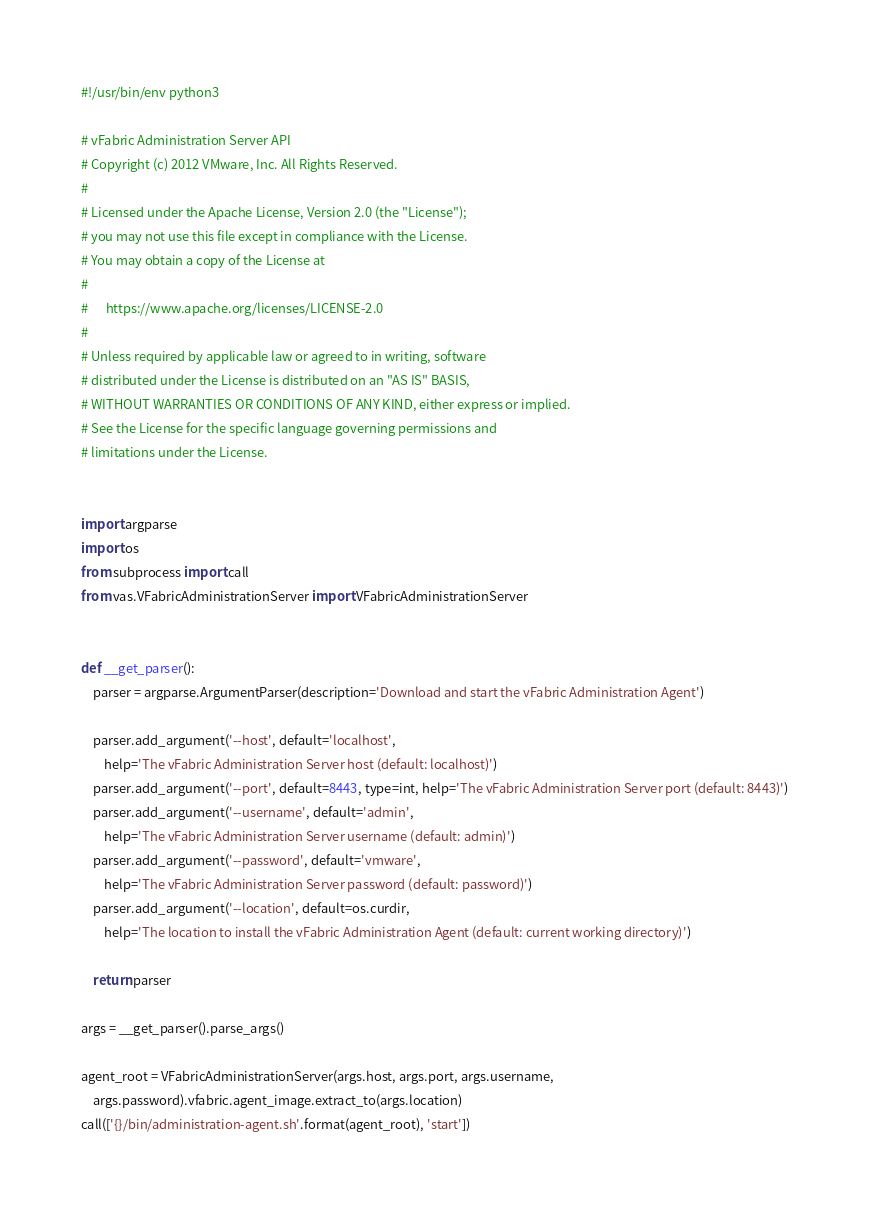Convert code to text. <code><loc_0><loc_0><loc_500><loc_500><_Python_>#!/usr/bin/env python3

# vFabric Administration Server API
# Copyright (c) 2012 VMware, Inc. All Rights Reserved.
#
# Licensed under the Apache License, Version 2.0 (the "License");
# you may not use this file except in compliance with the License.
# You may obtain a copy of the License at
#
#      https://www.apache.org/licenses/LICENSE-2.0
#
# Unless required by applicable law or agreed to in writing, software
# distributed under the License is distributed on an "AS IS" BASIS,
# WITHOUT WARRANTIES OR CONDITIONS OF ANY KIND, either express or implied.
# See the License for the specific language governing permissions and
# limitations under the License.


import argparse
import os
from subprocess import call
from vas.VFabricAdministrationServer import VFabricAdministrationServer


def __get_parser():
    parser = argparse.ArgumentParser(description='Download and start the vFabric Administration Agent')

    parser.add_argument('--host', default='localhost',
        help='The vFabric Administration Server host (default: localhost)')
    parser.add_argument('--port', default=8443, type=int, help='The vFabric Administration Server port (default: 8443)')
    parser.add_argument('--username', default='admin',
        help='The vFabric Administration Server username (default: admin)')
    parser.add_argument('--password', default='vmware',
        help='The vFabric Administration Server password (default: password)')
    parser.add_argument('--location', default=os.curdir,
        help='The location to install the vFabric Administration Agent (default: current working directory)')

    return parser

args = __get_parser().parse_args()

agent_root = VFabricAdministrationServer(args.host, args.port, args.username,
    args.password).vfabric.agent_image.extract_to(args.location)
call(['{}/bin/administration-agent.sh'.format(agent_root), 'start'])
</code> 